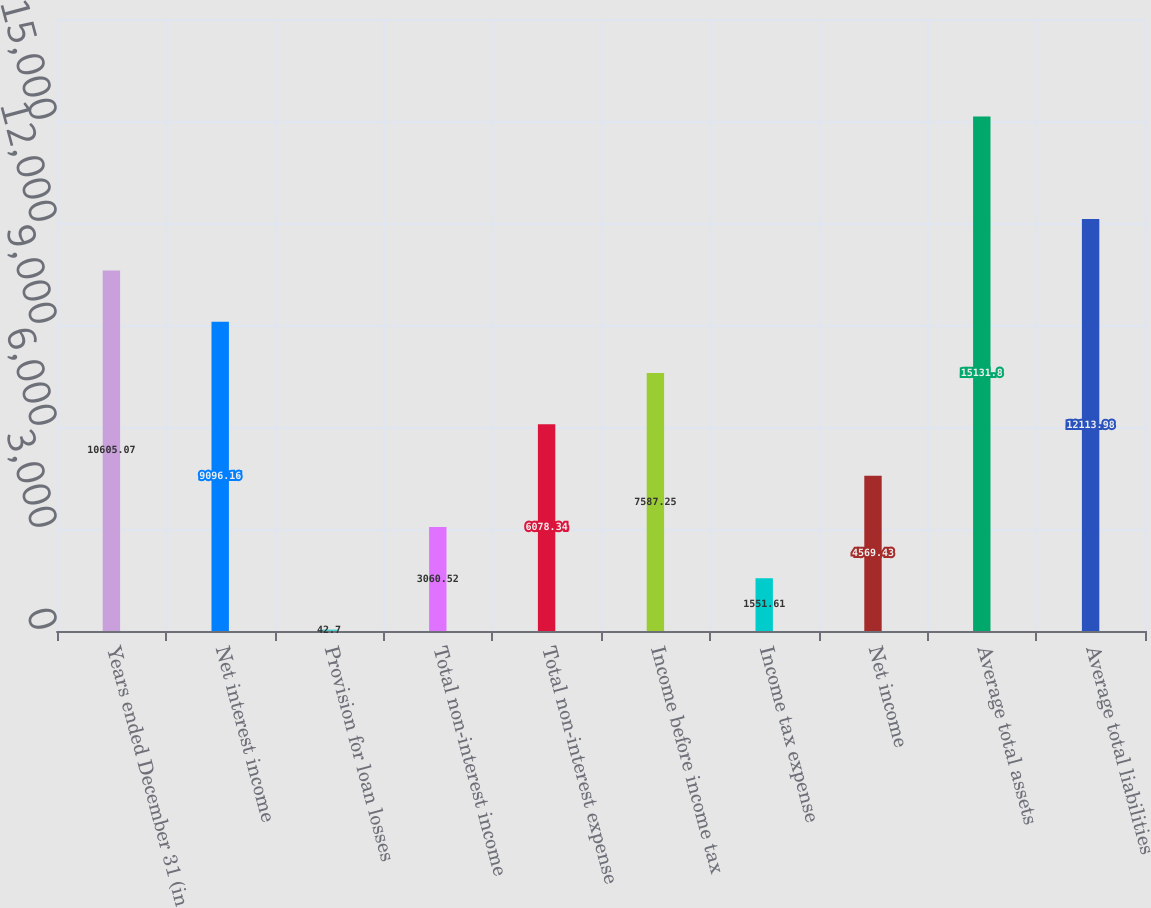Convert chart. <chart><loc_0><loc_0><loc_500><loc_500><bar_chart><fcel>Years ended December 31 (in<fcel>Net interest income<fcel>Provision for loan losses<fcel>Total non-interest income<fcel>Total non-interest expense<fcel>Income before income tax<fcel>Income tax expense<fcel>Net income<fcel>Average total assets<fcel>Average total liabilities<nl><fcel>10605.1<fcel>9096.16<fcel>42.7<fcel>3060.52<fcel>6078.34<fcel>7587.25<fcel>1551.61<fcel>4569.43<fcel>15131.8<fcel>12114<nl></chart> 